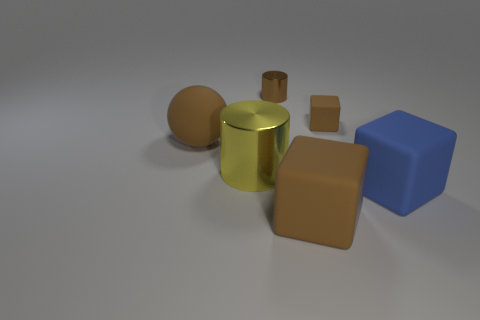Is there a small object of the same shape as the big yellow thing?
Make the answer very short. Yes. What shape is the yellow object that is the same size as the rubber ball?
Make the answer very short. Cylinder. What number of large matte spheres have the same color as the large cylinder?
Offer a very short reply. 0. There is a matte cube behind the blue matte cube; what is its size?
Offer a terse response. Small. What number of yellow cylinders are the same size as the brown metal thing?
Your answer should be very brief. 0. What is the color of the tiny cube that is made of the same material as the brown ball?
Keep it short and to the point. Brown. Is the number of large brown matte things behind the small brown matte cube less than the number of big yellow cylinders?
Ensure brevity in your answer.  Yes. There is a tiny object that is the same material as the big blue thing; what is its shape?
Provide a succinct answer. Cube. What number of rubber objects are either large green things or large blue things?
Your response must be concise. 1. Are there an equal number of big yellow objects that are behind the small brown cylinder and gray matte objects?
Keep it short and to the point. Yes. 